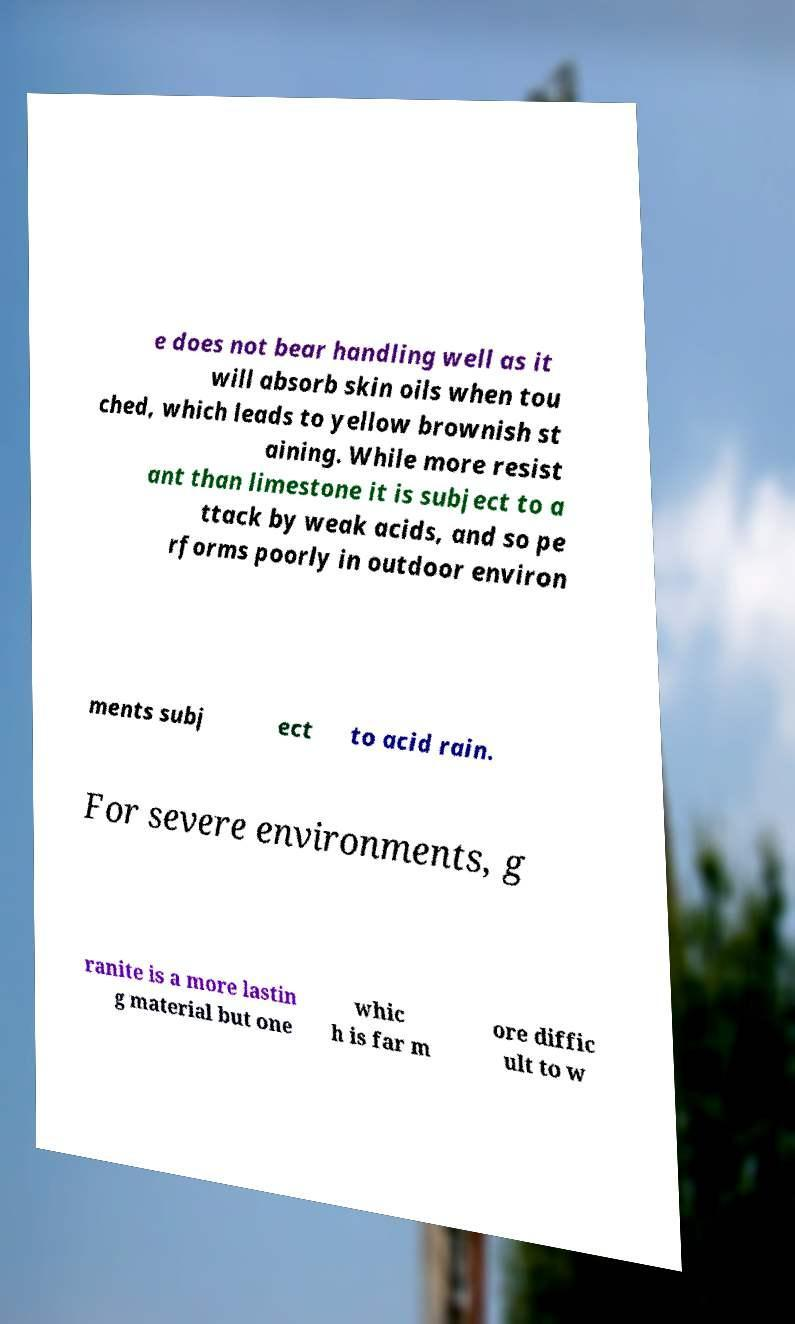There's text embedded in this image that I need extracted. Can you transcribe it verbatim? e does not bear handling well as it will absorb skin oils when tou ched, which leads to yellow brownish st aining. While more resist ant than limestone it is subject to a ttack by weak acids, and so pe rforms poorly in outdoor environ ments subj ect to acid rain. For severe environments, g ranite is a more lastin g material but one whic h is far m ore diffic ult to w 